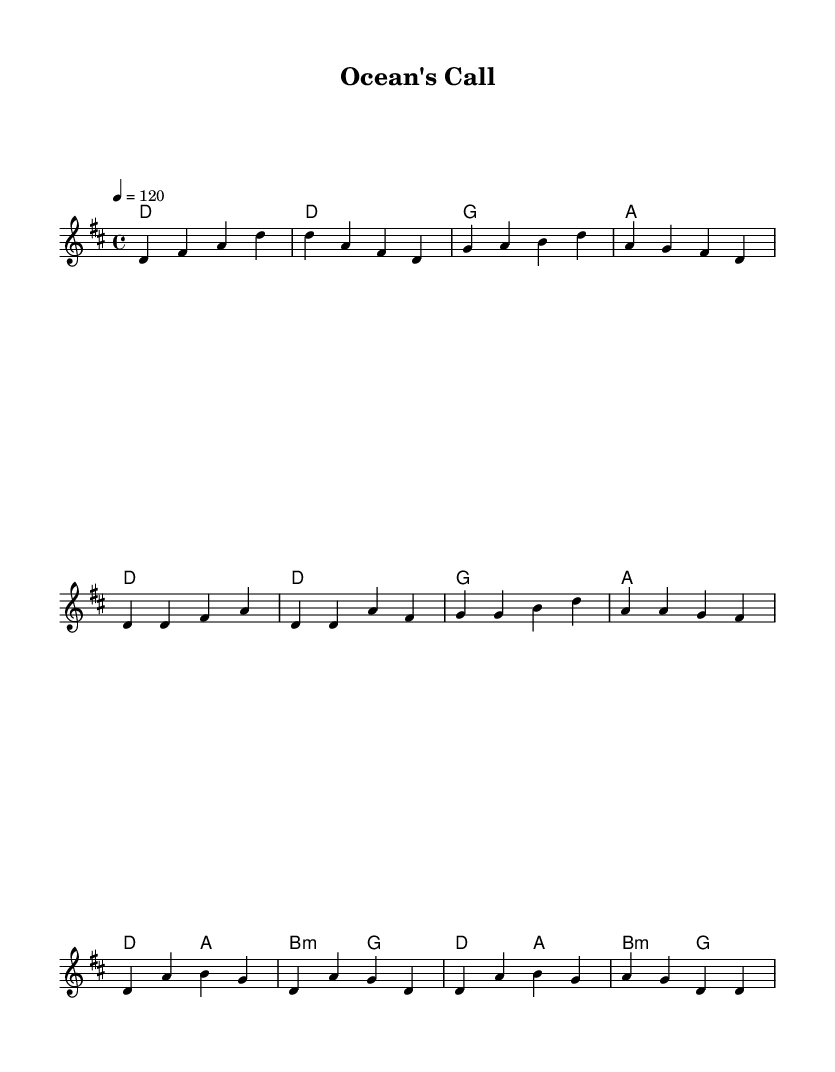What is the key signature of this music? The key signature is indicated at the beginning of the staff and shows two sharps, which are F# and C#. In this case, it corresponds to D major.
Answer: D major What is the time signature of the piece? The time signature is found at the beginning of the staff as well, indicated by the fraction 4/4, meaning there are four beats in each measure and a quarter note gets one beat.
Answer: 4/4 What is the tempo marking of this music? The tempo marking is located at the beginning with a metronome indication of 120, which tells the performer to play at 120 beats per minute.
Answer: 120 How many measures are in the verse section? By counting the measures in the verse section, we see that there are four measures in this part. Each measure corresponds to a line of melodic and harmonic content.
Answer: 4 What are the starting notes of the melody in the chorus? The chorus starts with the notes D, A, and B, based on the first measure of the chorus where D is followed by A and B in the sequence described.
Answer: D, A, B What is the tempo marking of the piece? The tempo marking indicates the speed of the piece and is noted at the beginning of the music, stating to play at a tempo of 120 beats per minute, which guides the performer on how briskly to play the piece.
Answer: 120 What is the thematic content of the lyrics in the chorus? The chorus lyrics reflect a yearning for the ocean and the freedom of sailing, suggesting a connection back to the ocean theme prominent in the music. The words state "Ocean's call, it beckons me," which emphasizes this theme.
Answer: Ocean's call 